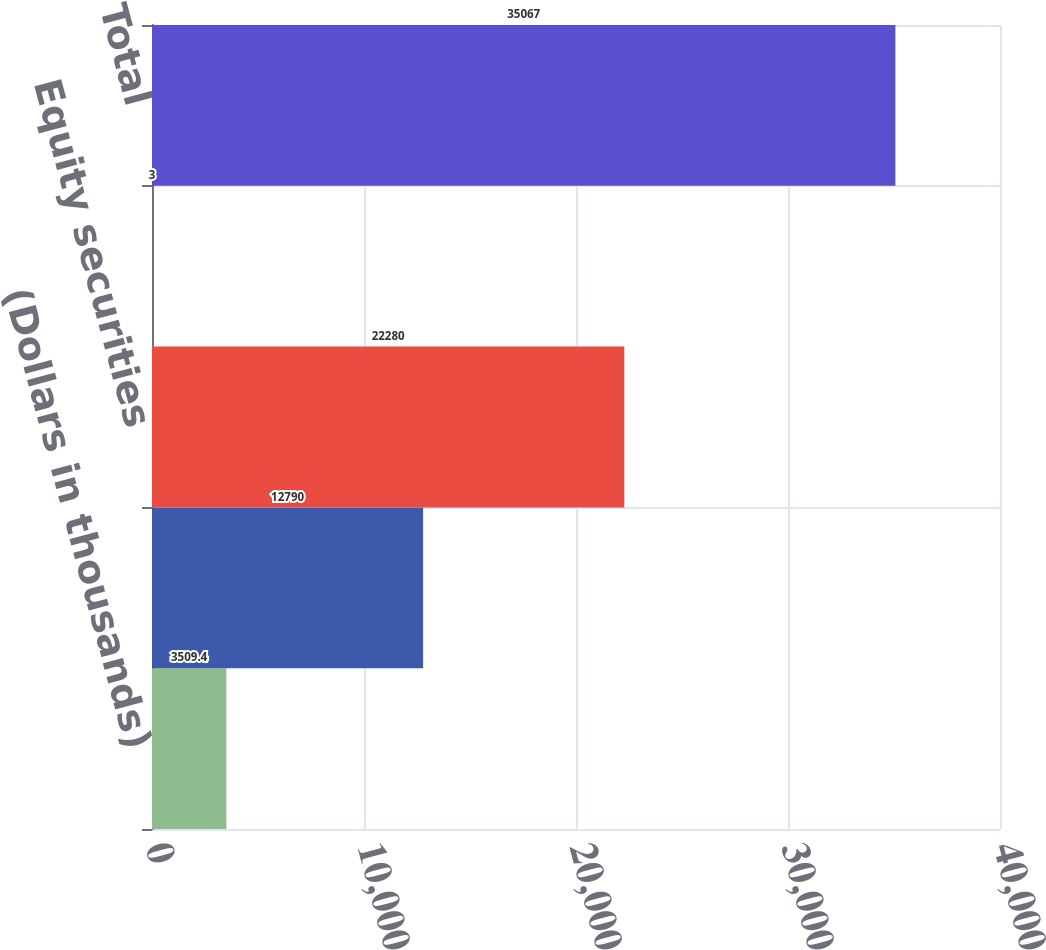Convert chart to OTSL. <chart><loc_0><loc_0><loc_500><loc_500><bar_chart><fcel>(Dollars in thousands)<fcel>Fixed maturities<fcel>Equity securities<fcel>Short-term investments<fcel>Total<nl><fcel>3509.4<fcel>12790<fcel>22280<fcel>3<fcel>35067<nl></chart> 